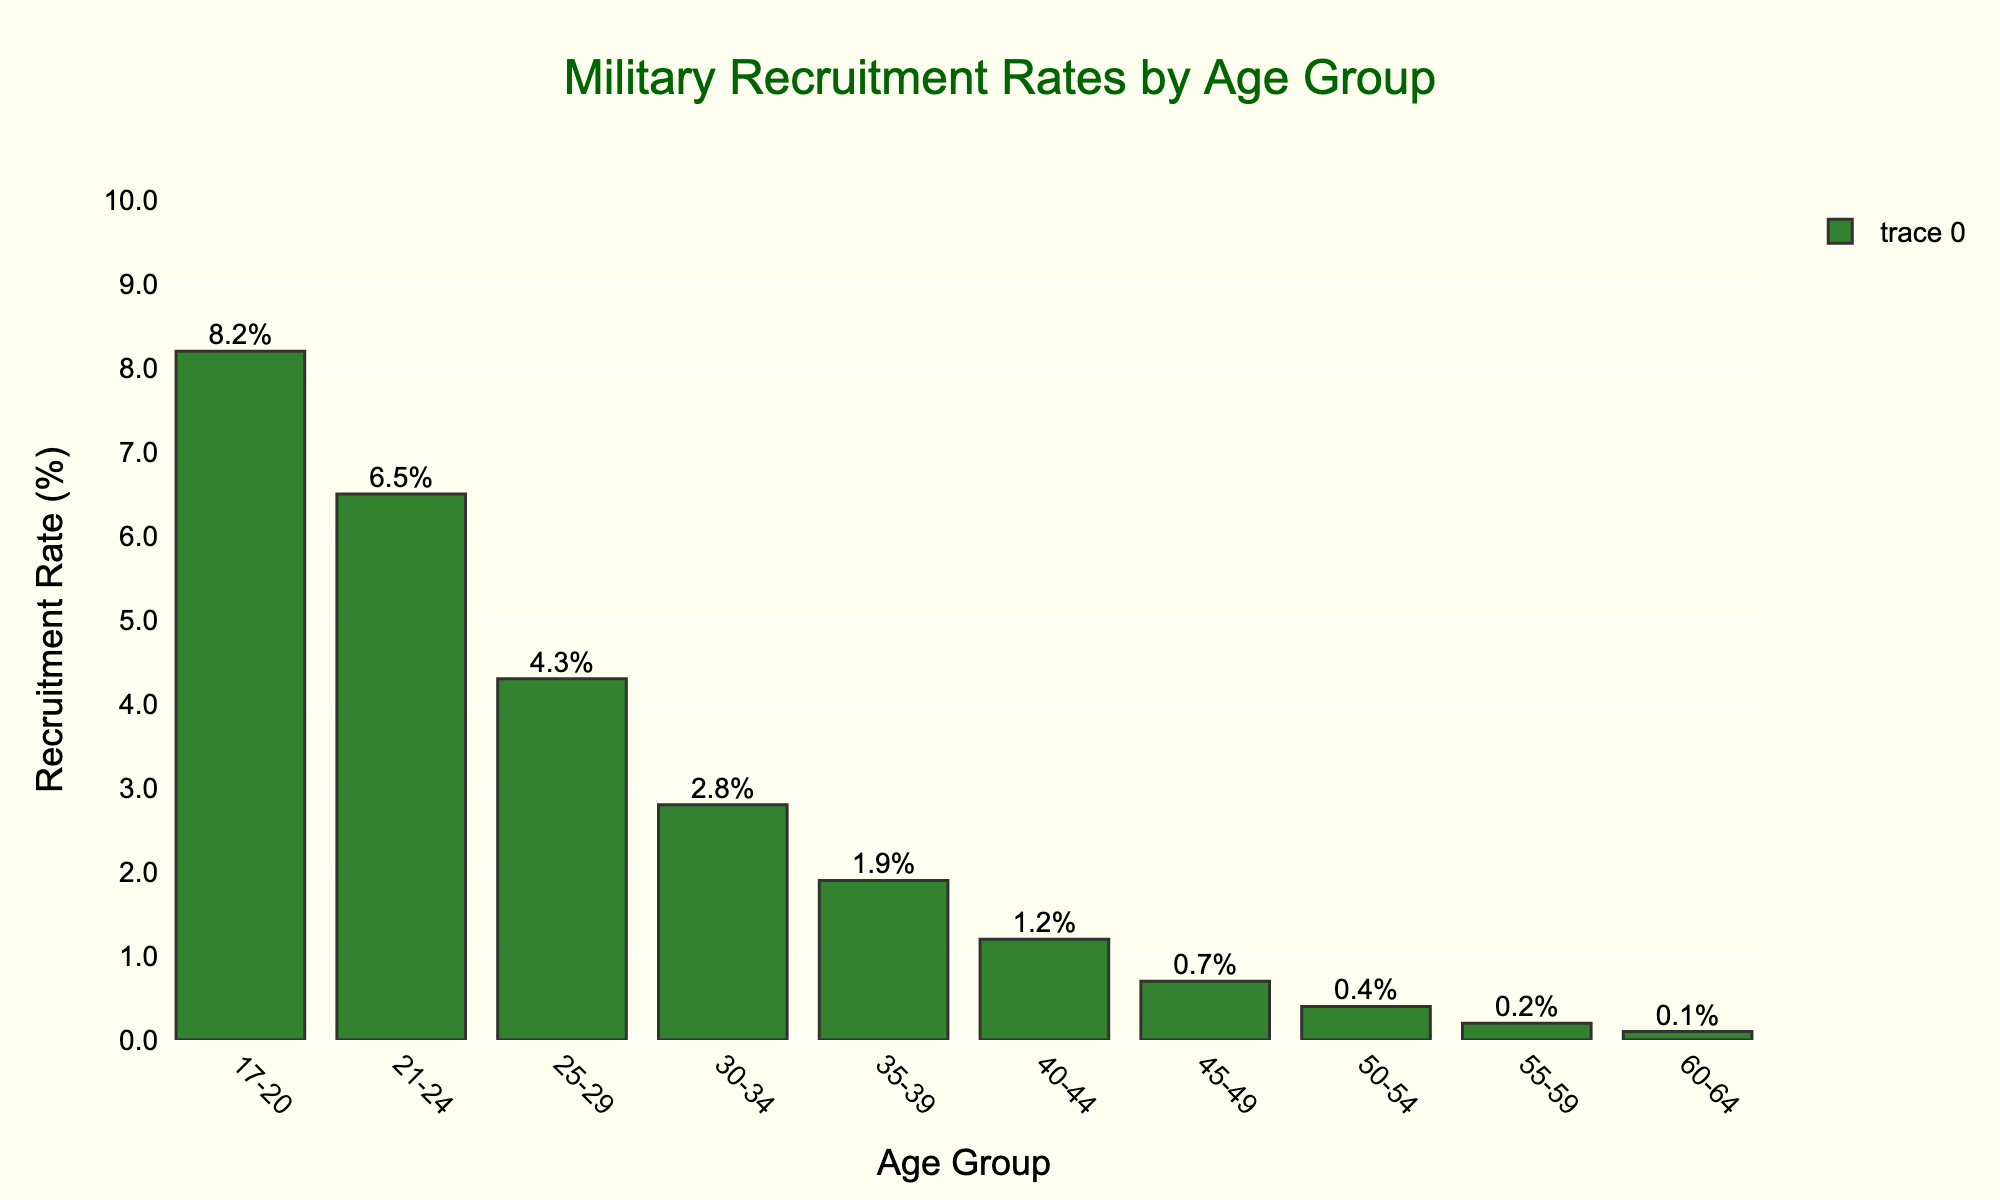What's the age group with the highest recruitment rate? The age group 17-20 has the highest recruitment rate at 8.2%. This can be observed by comparing the height of the bars in the chart, where the bar representing the age group 17-20 is the tallest.
Answer: 17-20 By how much does the recruitment rate decrease from the 17-20 age group to the 21-24 age group? The recruitment rate for the 17-20 age group is 8.2%, and for the 21-24 age group, it is 6.5%. Subtracting these gives 8.2% - 6.5% = 1.7%.
Answer: 1.7% What is the total recruitment rate for the age groups 17-20 and 21-24 combined? The recruitment rate for the 17-20 age group is 8.2%, and for the 21-24 age group, it is 6.5%. Adding these gives 8.2% + 6.5% = 14.7%.
Answer: 14.7% What is the average recruitment rate across all age groups? To find the average recruitment rate, sum all the recruitment rates and divide by the number of age groups: (8.2 + 6.5 + 4.3 + 2.8 + 1.9 + 1.2 + 0.7 + 0.4 + 0.2 + 0.1) / 10 = 26.3 / 10 = 2.63%.
Answer: 2.63% Which age groups have a recruitment rate below 1%? The age groups with recruitment rates below 1% are 40-44 (1.2%), 45-49 (0.7%), 50-54 (0.4%), 55-59 (0.2%), and 60-64 (0.1%). This can be observed by looking at the corresponding bars in the chart.
Answer: 45-49, 50-54, 55-59, 60-64 How does the recruitment rate change as age increases from 30-34 to 40-44? The recruitment rate for the 30-34 age group is 2.8%, for 35-39 it is 1.9%, and for 40-44 it is 1.2%. The rate decreases as age increases: 2.8% to 1.9%, then 1.9% to 1.2%, showing a steady decline.
Answer: It decreases What is the difference in recruitment rate between the 25-29 age group and the 50-54 age group? The recruitment rate for the 25-29 age group is 4.3%, and for the 50-54 age group, it is 0.4%. The difference is 4.3% - 0.4% = 3.9%.
Answer: 3.9% Which age group has the smallest recruitment rate, and what is it? The 60-64 age group has the smallest recruitment rate at 0.1%. This is visible by observing the shortest bar in the chart.
Answer: 60-64, 0.1% How do the recruitment rates for the 17-20 and 25-29 age groups compare visually? The bar for the 17-20 age group is taller than the bar for the 25-29 age group. This indicates that the recruitment rate for the 17-20 age group (8.2%) is higher than that for the 25-29 age group (4.3%).
Answer: 17-20 is higher What is the combined recruitment rate for the age groups over 50? Sum the recruitment rates for the age groups 50-54 (0.4%), 55-59 (0.2%), and 60-64 (0.1%): 0.4% + 0.2% + 0.1% = 0.7%.
Answer: 0.7% 